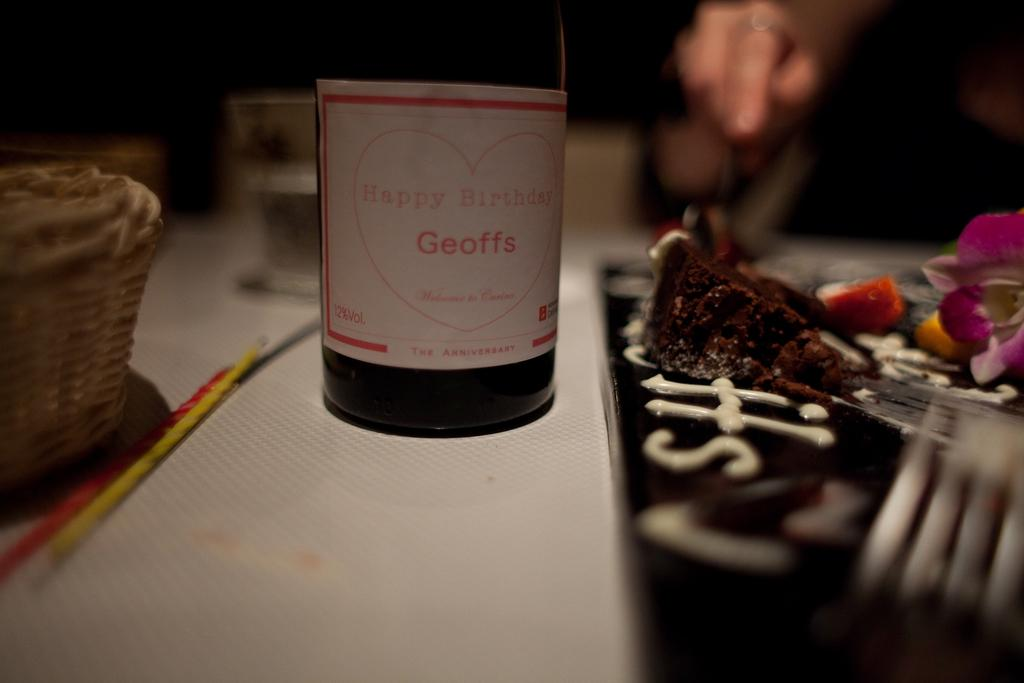<image>
Provide a brief description of the given image. The label on a bottle says Happy Birthday Geoffs. 